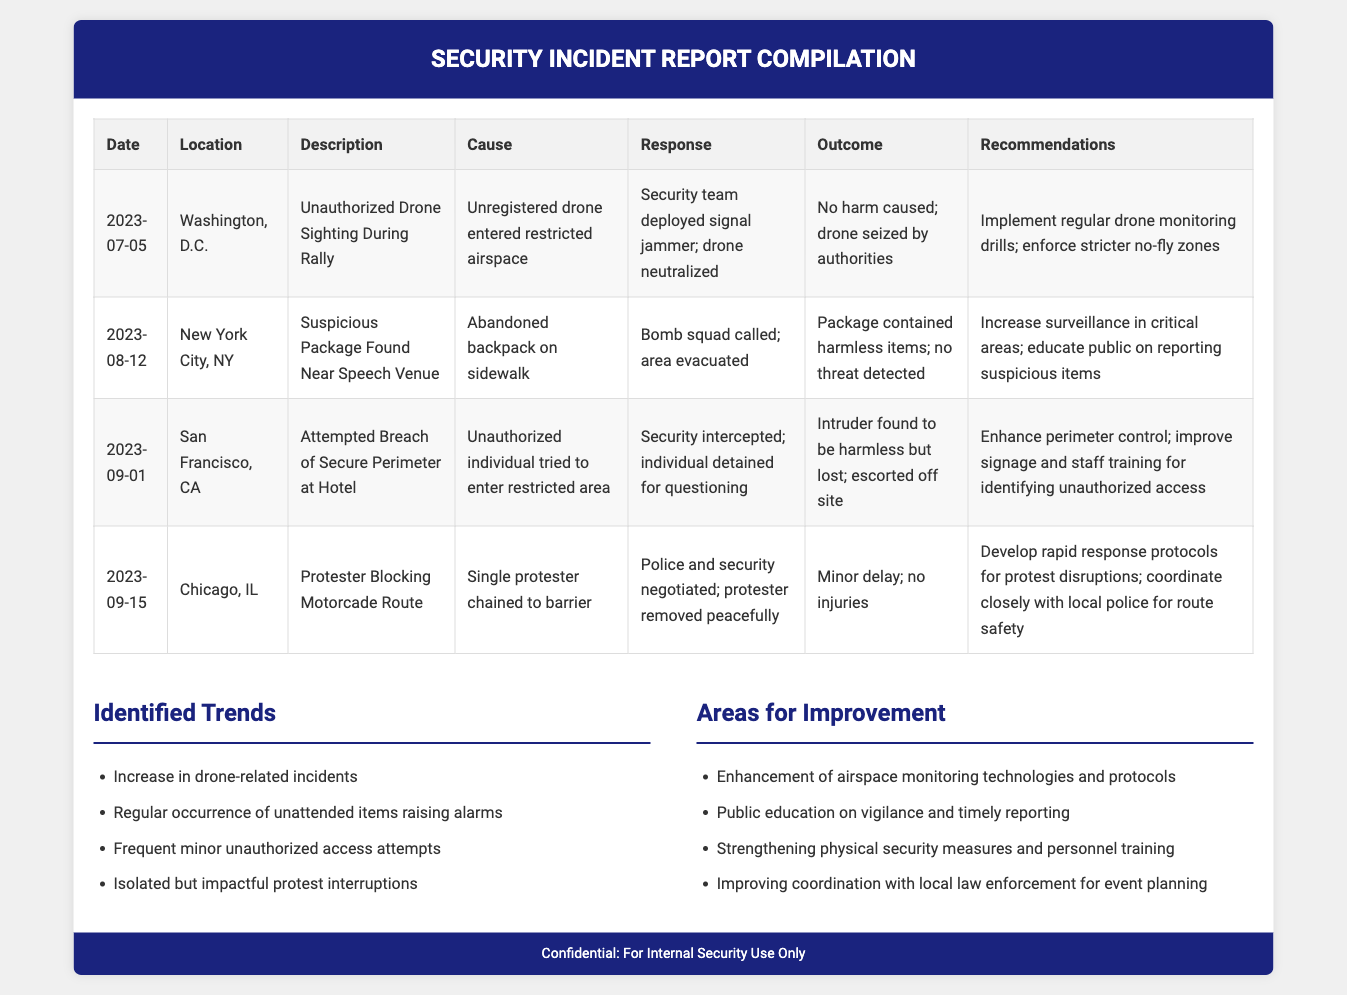What was the date of the unauthorized drone sighting? The date of the unauthorized drone sighting is listed in the first row of the table as July 5, 2023.
Answer: July 5, 2023 What located the suspicious package? The suspicious package was found near the speech venue, specifically indicated in the table.
Answer: Near speech venue What was the outcome of the attempted breach of secure perimeter? The outcome of the attempted breach is detailed in the table and states that the intruder was found to be harmless but lost, and was escorted off site.
Answer: Harmless but lost How many incidents involved drones in the last quarter? The document lists one specific incident related to drones, found in the first row of the table.
Answer: One What is one recommendation for improving drone incident response? The recommendation for improving response is provided in the recommendations column of the first incident row, emphasizing regular drone monitoring drills.
Answer: Implement regular drone monitoring drills What is a trend identified in the report? The report identifies multiple trends, one of which is found in the trends section, specifically noting an increase in drone-related incidents.
Answer: Increase in drone-related incidents What was a cause of the suspicious package incident? The cause of the suspicious package incident is noted in the table as an abandoned backpack on the sidewalk.
Answer: Abandoned backpack What two areas for improvement are mentioned in the report? Two areas for improvement are listed in the improvements section, such as enhancing airspace monitoring and public education on vigilance.
Answer: Enhancement of airspace monitoring, public education on vigilance What was the response to the protester blocking the motorcade route? The response to the protester is detailed in the table, stating that police and security negotiated, resulting in the protester being removed peacefully.
Answer: Police and security negotiated 